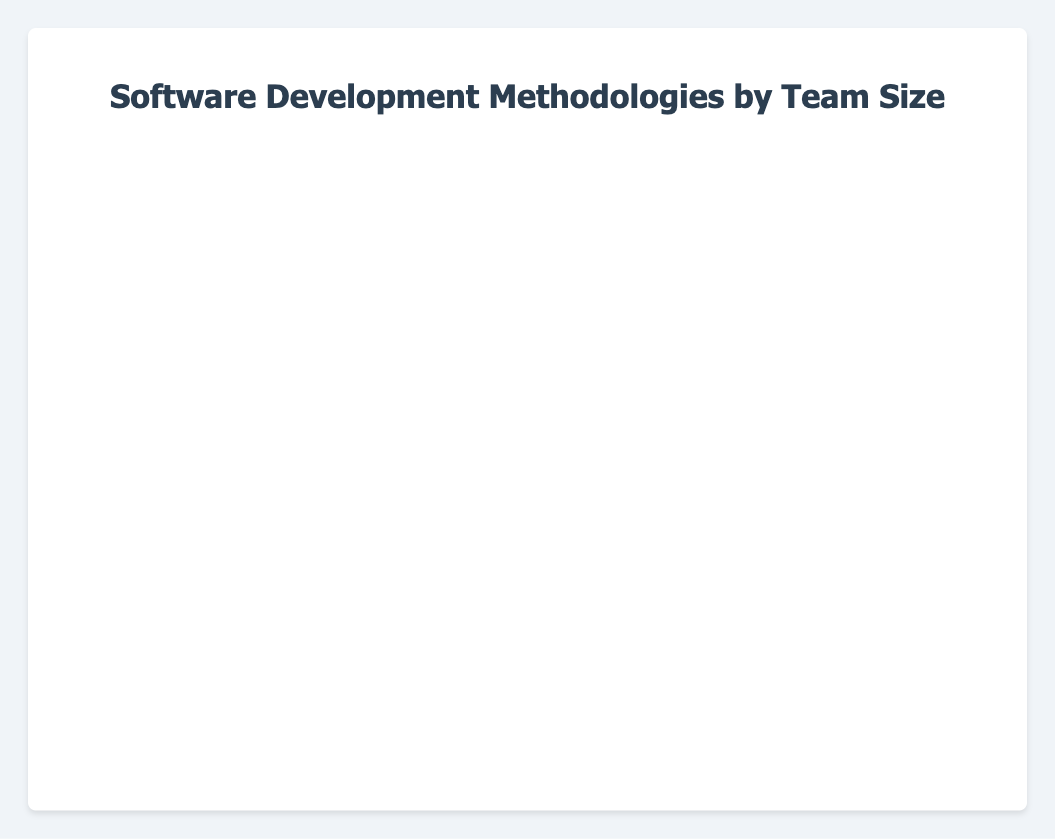What software development methodology has the highest adoption rate for small teams? The methodology with the longest blue bar represents the small team adoption rate. Agile shows the longest blue bar.
Answer: Agile Which methodology has the least adoption for large teams? The methodology with the shortest red bar represents the large team adoption rate. Waterfall has the shortest red bar.
Answer: Waterfall What is the combined adoption rate for medium and large teams in the Lean methodology? For Lean, sum the lengths of the green bar (medium team) and the red bar (large team). The values are 40 (medium team) + 55 (large team) = 95.
Answer: 95 Compare the adoption rate for small teams in Extreme Programming (XP) and Feature-Driven Development (FDD). Which one is higher? The adoption rates for small teams are 35 for XP and 25 for FDD. Since 35 > 25, XP has a higher adoption rate.
Answer: Extreme Programming (XP) Which methodology shows the smallest difference between medium and large team adoption rates? Calculate the difference between the green (medium) and red (large) bars for each methodology and find the smallest difference. Spiral Model shows 30 - 40 = 10, the smallest difference.
Answer: Spiral Model In terms of medium-sized team adoption, which methodology ranks third? Medium team adoption rates are represented by green bars. Sorted values are 70, 65, 60, 50, 50, 45, 40, 35, 35, 30. Thus, Scrum (60) ranks third.
Answer: Scrum What is the average adoption rate of small teams across all methodologies? Sum all the blue bars representing small team adoption rates and divide by the number of methodologies: (20 + 50 + 40 + 30 + 25 + 35 + 45 + 25 + 30 + 20) / 10 = 32
Answer: 32 Which methodology demonstrates the highest total combined adoption across all team sizes? Sum the adoption rates (blue + green + red) for each methodology and find the highest. Agile: 50 + 70 + 90 = 210, Scrum: 40 + 60 + 80 = 180, Waterfall: 20 + 35 + 45 = 100, etc. Agile has the highest total of 210.
Answer: Agile How does the adoption rate for large teams in Kanban compare to that of Scrum? Large team adoption rates are represented by the red bars: Kanban is 50, Scrum is 80. Scrum's adoption is higher.
Answer: Scrum What is the total adoption rate for DevOps across small, medium, and large teams? Sum the numbers for DevOps: 45 (small) + 65 (medium) + 85 (large) = 195.
Answer: 195 